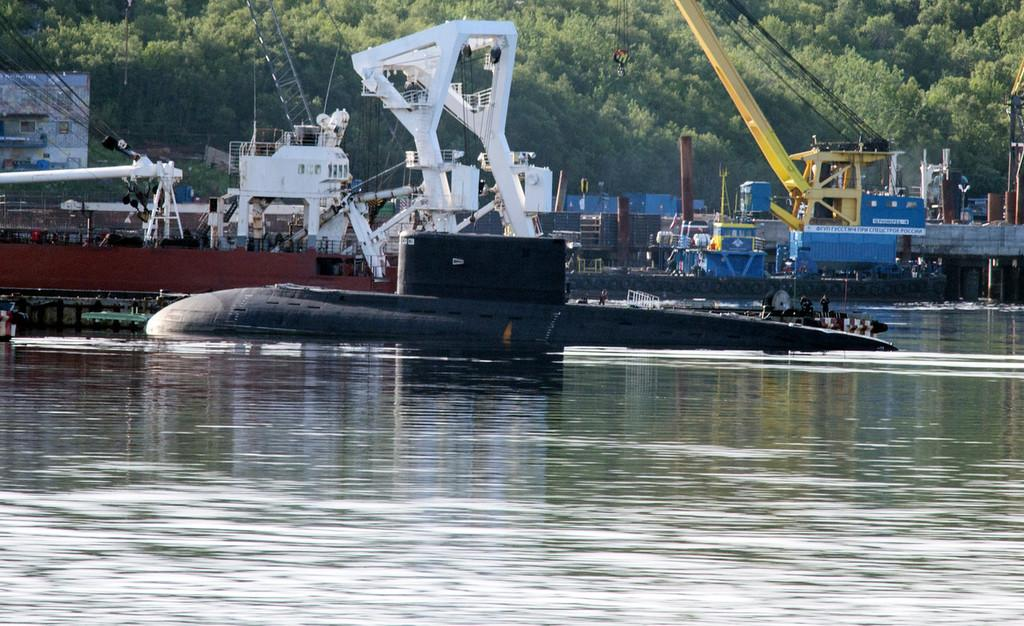What is in the water in the image? There are objects in the water in the image. Can you describe the appearance of the objects? The objects are in different colors. What can be seen in the background of the image? There are trees and a building visible in the background. What shape is the hope taking in the image? There is no mention of hope or any shape in the image; it features objects in the water and a background with trees and a building. 